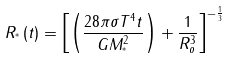<formula> <loc_0><loc_0><loc_500><loc_500>R _ { ^ { * } } \left ( t \right ) = \left [ \left ( \frac { 2 8 \pi \sigma T ^ { 4 } t } { G M _ { ^ { * } } ^ { 2 } } \right ) + \frac { 1 } { R _ { o } ^ { 3 } } \right ] ^ { - \frac { 1 } { 3 } }</formula> 